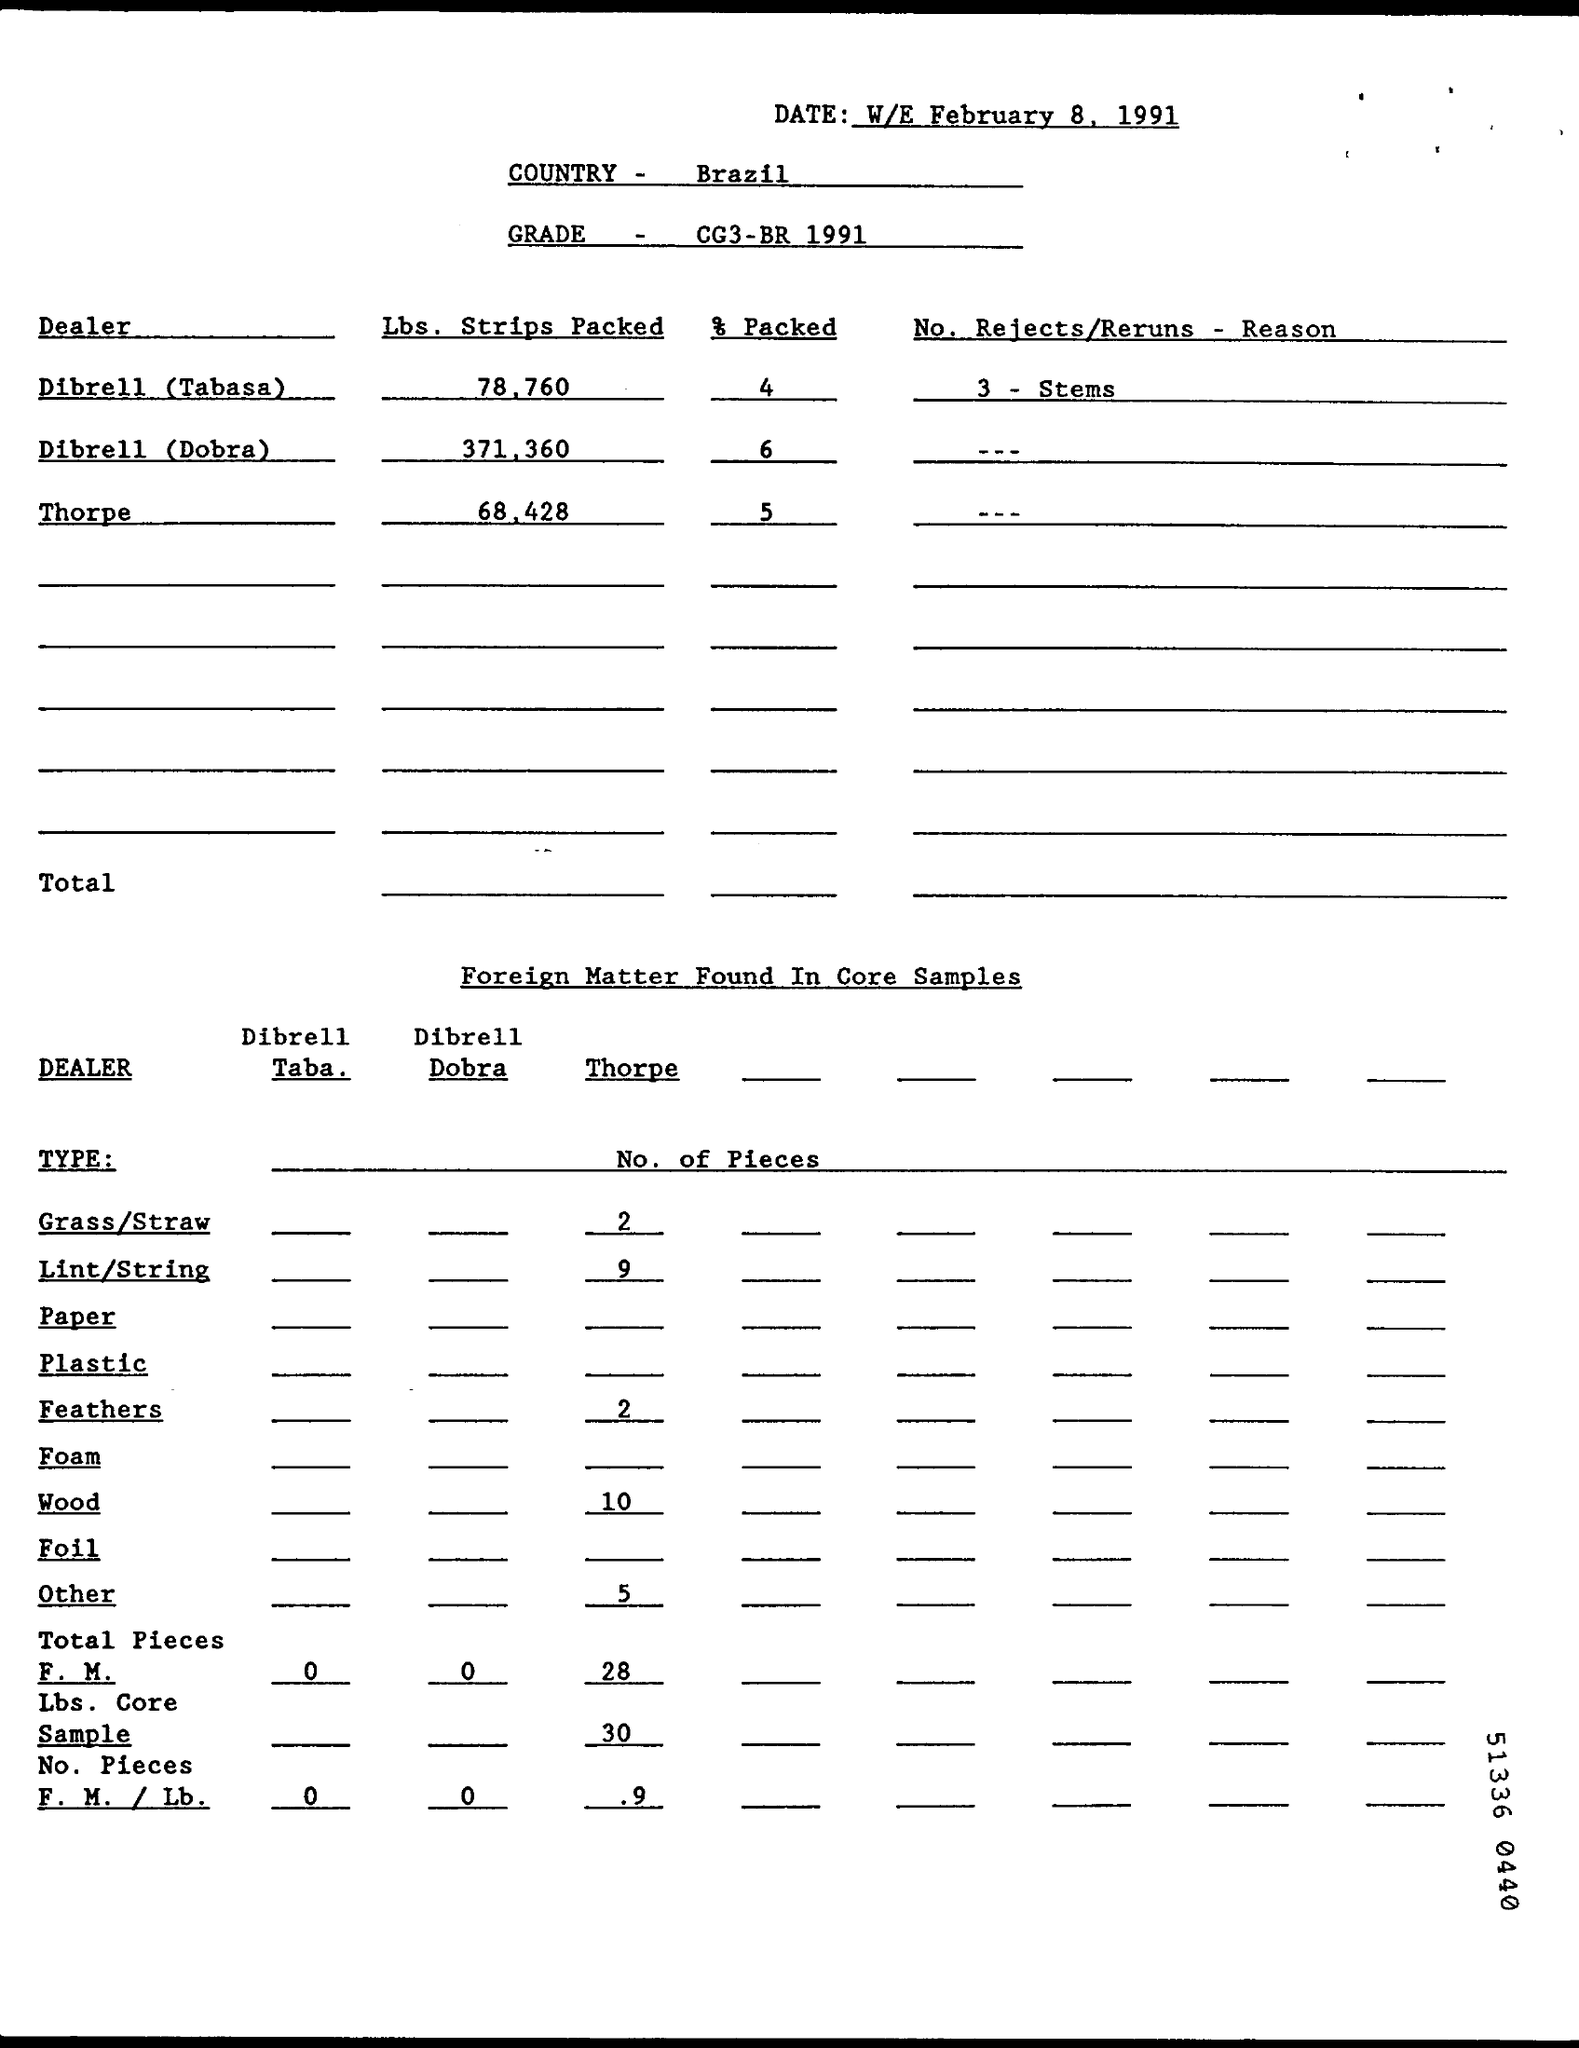Point out several critical features in this image. The grade specified is CG3, according to the BR 1991 standard. Out of the total packing done, Dibrell (Dobra) packed 6% of the items. There were three rejections or reruns from Dibrell (Tabasa). This was discovered after a thorough investigation. Brazil is mentioned. Nine pieces of lint/string were found from Thorpe. 